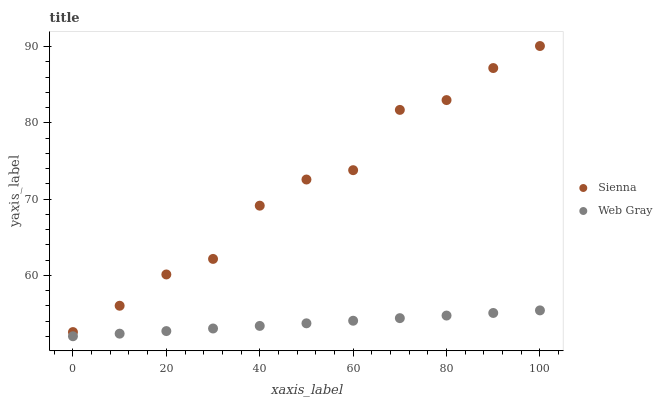Does Web Gray have the minimum area under the curve?
Answer yes or no. Yes. Does Sienna have the maximum area under the curve?
Answer yes or no. Yes. Does Web Gray have the maximum area under the curve?
Answer yes or no. No. Is Web Gray the smoothest?
Answer yes or no. Yes. Is Sienna the roughest?
Answer yes or no. Yes. Is Web Gray the roughest?
Answer yes or no. No. Does Web Gray have the lowest value?
Answer yes or no. Yes. Does Sienna have the highest value?
Answer yes or no. Yes. Does Web Gray have the highest value?
Answer yes or no. No. Is Web Gray less than Sienna?
Answer yes or no. Yes. Is Sienna greater than Web Gray?
Answer yes or no. Yes. Does Web Gray intersect Sienna?
Answer yes or no. No. 